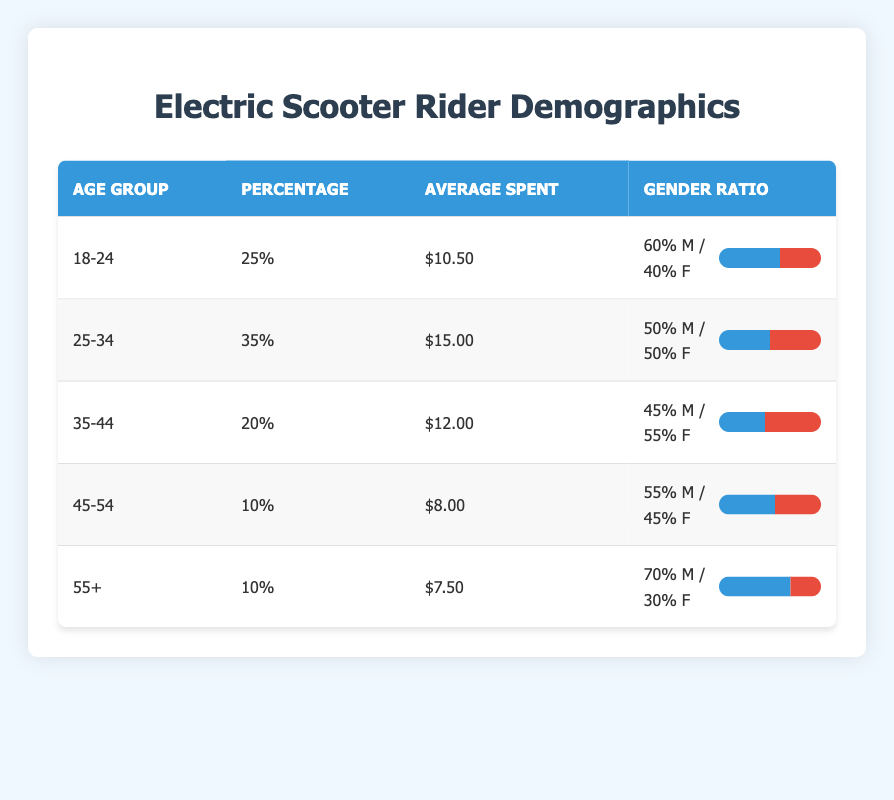What is the percentage of electric scooter riders aged 25-34? According to the table, the age group 25-34 has a listed percentage of 35%.
Answer: 35% What is the average amount spent by riders aged 18-24? The table states that riders in the age group 18-24 spent an average of $10.50.
Answer: $10.50 Is the gender distribution in the 35-44 age group equal? The gender ratio shows 45% male and 55% female, indicating it is not equal.
Answer: No What is the total percentage of riders aged 45 and older? The combined percentage of riders aged 45-54 and 55+ is 10% + 10%, which totals to 20%.
Answer: 20% Which age group has the highest average spent per rider? By reviewing the average spent amounts, 25-34 has the highest average at $15.00 compared to others.
Answer: 25-34 What is the average gender ratio of male riders across all age groups? The male percentages are 60%, 50%, 45%, 55%, and 70%. The average is (60 + 50 + 45 + 55 + 70) / 5 = 54%.
Answer: 54% Is it true that riders aged 55+ spent less on average than those aged 45-54? The average spent for 55+ is $7.50, which is less than $8.00 for 45-54, confirming the statement.
Answer: Yes What age group has the lowest average spending? Looking at the average spending values, the 55+ age group has the lowest average at $7.50.
Answer: 55+ What is the gender ratio for riders aged 45-54? The gender ratio for 45-54 shows 55% male and 45% female.
Answer: 55% male / 45% female 